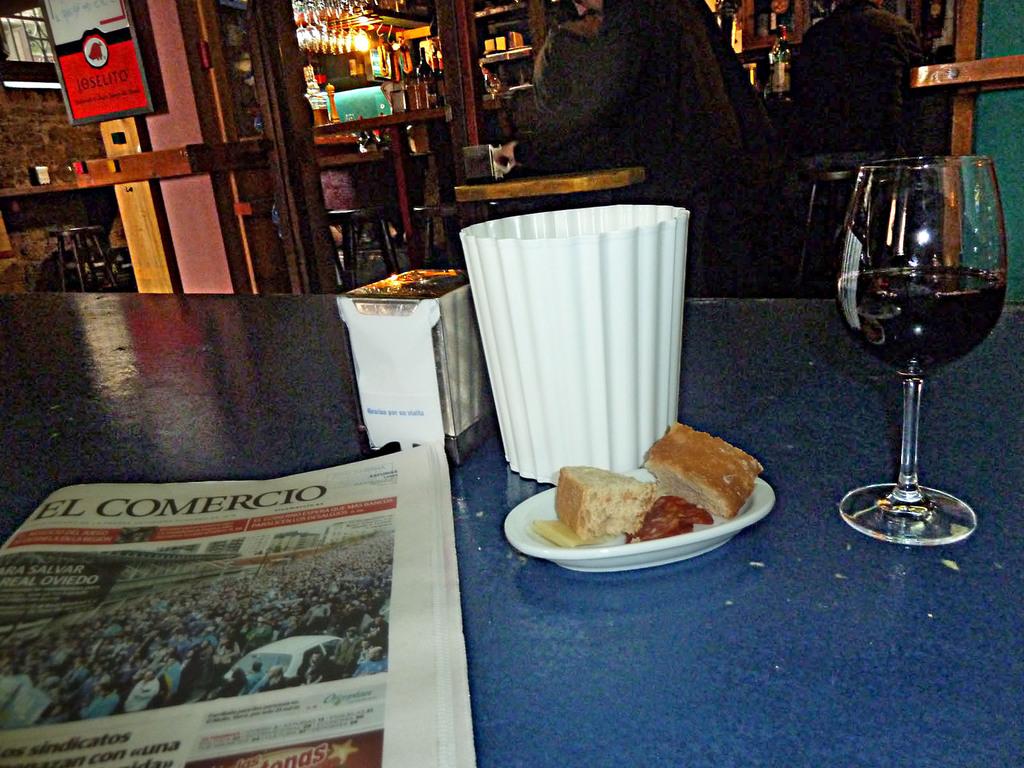What is the newspaper title?
Offer a very short reply. El comercio. What word starts with an s written in a black box on the paper photo?
Offer a terse response. Salvar. 